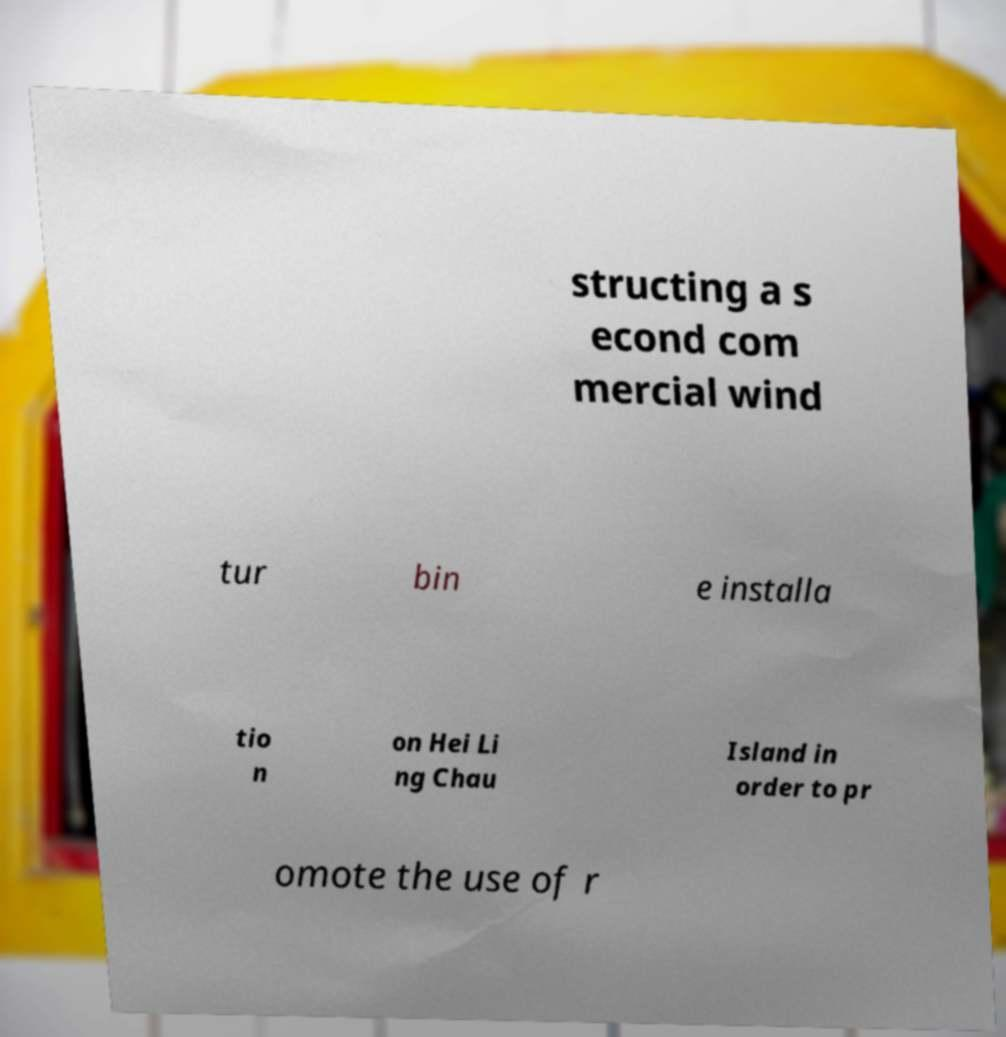I need the written content from this picture converted into text. Can you do that? structing a s econd com mercial wind tur bin e installa tio n on Hei Li ng Chau Island in order to pr omote the use of r 